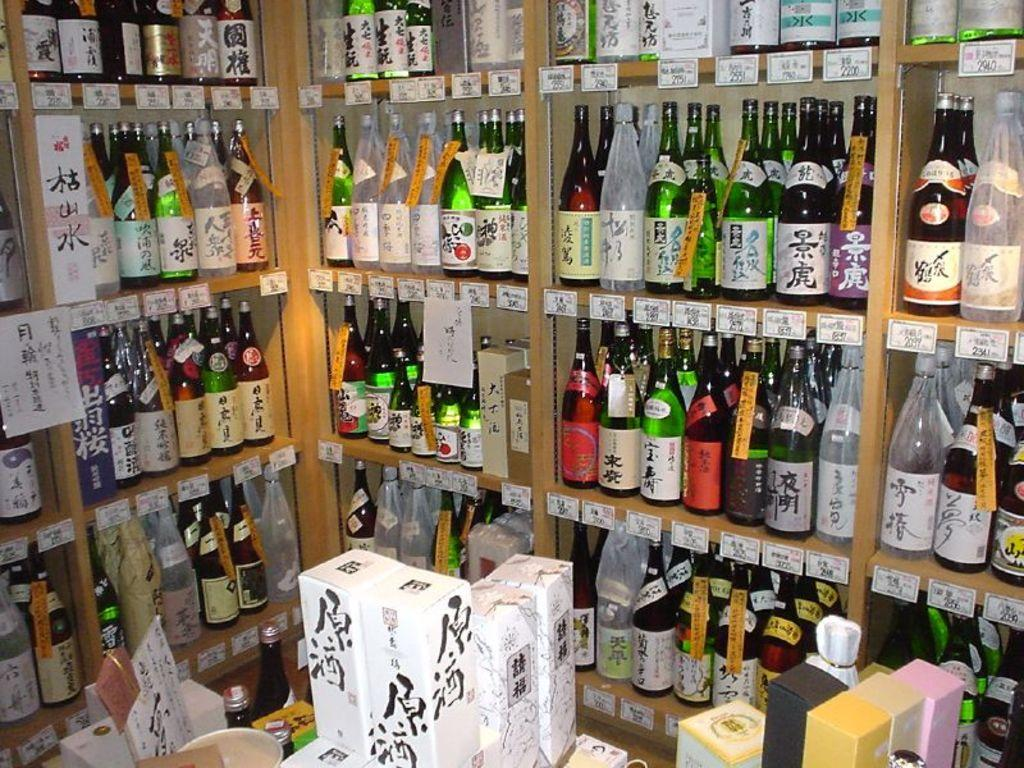What objects are arranged on the shelf in the image? There are many bottles arranged on a shelf in the image. What other items can be seen in the image besides the bottles on the shelf? There are few boxes and a bowl on a table in the image. Is there any paper visible in the image? Yes, there is a paper on the shelf in the image. Can you see a rabbit in the image? No, there is no rabbit present in the image. What type of can is visible in the image? There is no can present in the image; it only features bottles, boxes, a bowl, and a paper. 